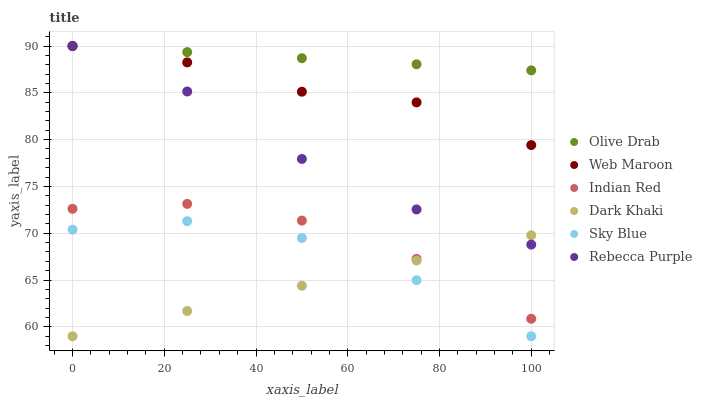Does Dark Khaki have the minimum area under the curve?
Answer yes or no. Yes. Does Olive Drab have the maximum area under the curve?
Answer yes or no. Yes. Does Rebecca Purple have the minimum area under the curve?
Answer yes or no. No. Does Rebecca Purple have the maximum area under the curve?
Answer yes or no. No. Is Dark Khaki the smoothest?
Answer yes or no. Yes. Is Indian Red the roughest?
Answer yes or no. Yes. Is Rebecca Purple the smoothest?
Answer yes or no. No. Is Rebecca Purple the roughest?
Answer yes or no. No. Does Dark Khaki have the lowest value?
Answer yes or no. Yes. Does Rebecca Purple have the lowest value?
Answer yes or no. No. Does Olive Drab have the highest value?
Answer yes or no. Yes. Does Dark Khaki have the highest value?
Answer yes or no. No. Is Indian Red less than Rebecca Purple?
Answer yes or no. Yes. Is Rebecca Purple greater than Sky Blue?
Answer yes or no. Yes. Does Rebecca Purple intersect Dark Khaki?
Answer yes or no. Yes. Is Rebecca Purple less than Dark Khaki?
Answer yes or no. No. Is Rebecca Purple greater than Dark Khaki?
Answer yes or no. No. Does Indian Red intersect Rebecca Purple?
Answer yes or no. No. 